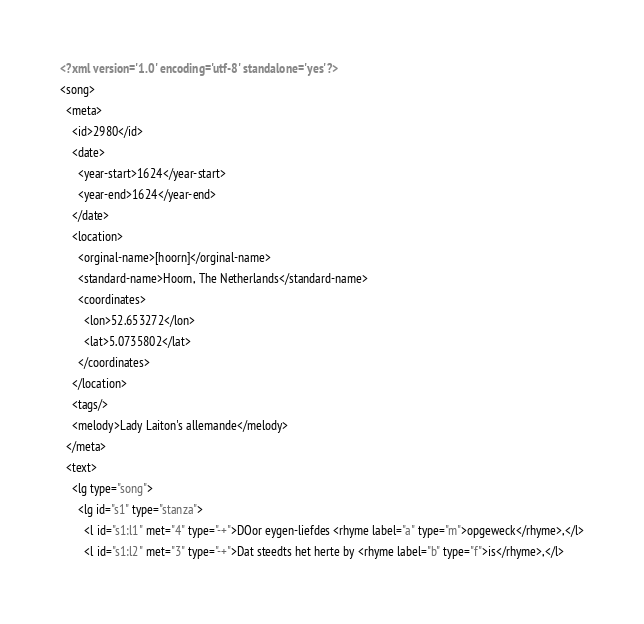<code> <loc_0><loc_0><loc_500><loc_500><_XML_><?xml version='1.0' encoding='utf-8' standalone='yes'?>
<song>
  <meta>
    <id>2980</id>
    <date>
      <year-start>1624</year-start>
      <year-end>1624</year-end>
    </date>
    <location>
      <orginal-name>[hoorn]</orginal-name>
      <standard-name>Hoorn, The Netherlands</standard-name>
      <coordinates>
        <lon>52.653272</lon>
        <lat>5.0735802</lat>
      </coordinates>
    </location>
    <tags/>
    <melody>Lady Laiton's allemande</melody>
  </meta>
  <text>
    <lg type="song">
      <lg id="s1" type="stanza">
        <l id="s1:l1" met="4" type="-+">DOor eygen-liefdes <rhyme label="a" type="m">opgeweck</rhyme>,</l>
        <l id="s1:l2" met="3" type="-+">Dat steedts het herte by <rhyme label="b" type="f">is</rhyme>,</l></code> 